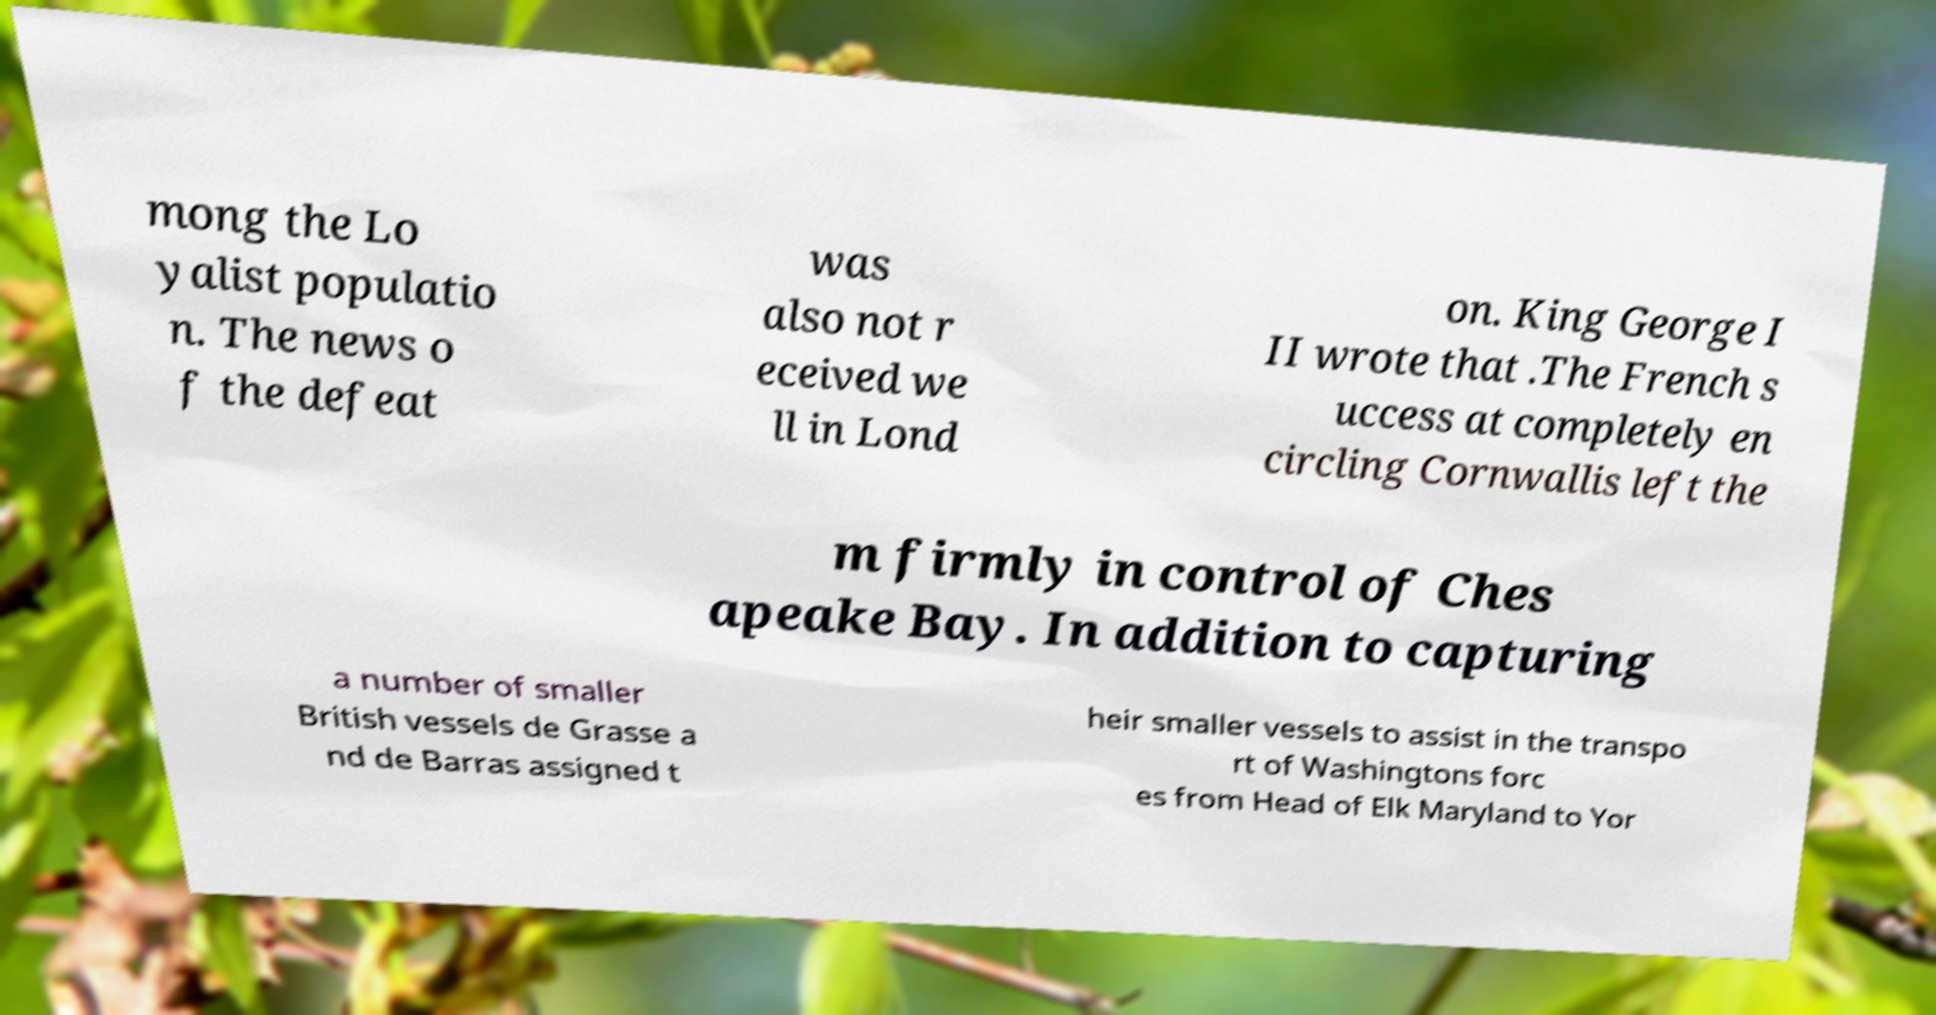Please identify and transcribe the text found in this image. mong the Lo yalist populatio n. The news o f the defeat was also not r eceived we ll in Lond on. King George I II wrote that .The French s uccess at completely en circling Cornwallis left the m firmly in control of Ches apeake Bay. In addition to capturing a number of smaller British vessels de Grasse a nd de Barras assigned t heir smaller vessels to assist in the transpo rt of Washingtons forc es from Head of Elk Maryland to Yor 